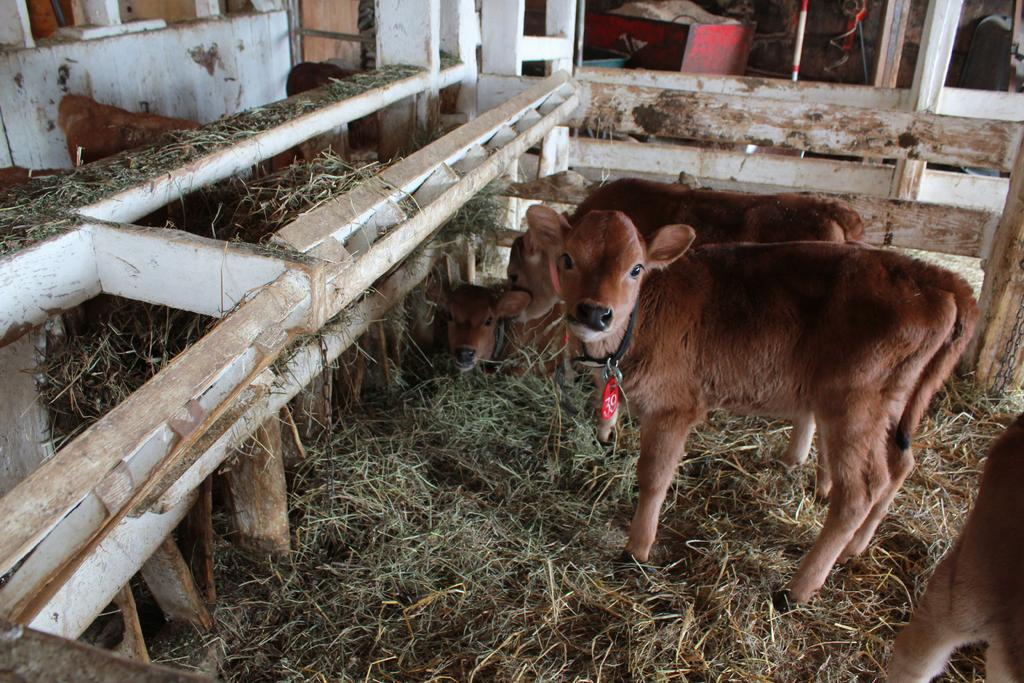What types of living organisms can be seen in the image? There are animals in the image. What type of vegetation is present in the image? There is grass in the image. What type of magic is being performed by the animals in the image? There is no magic being performed by the animals in the image, as there is no indication of any magical activity. 